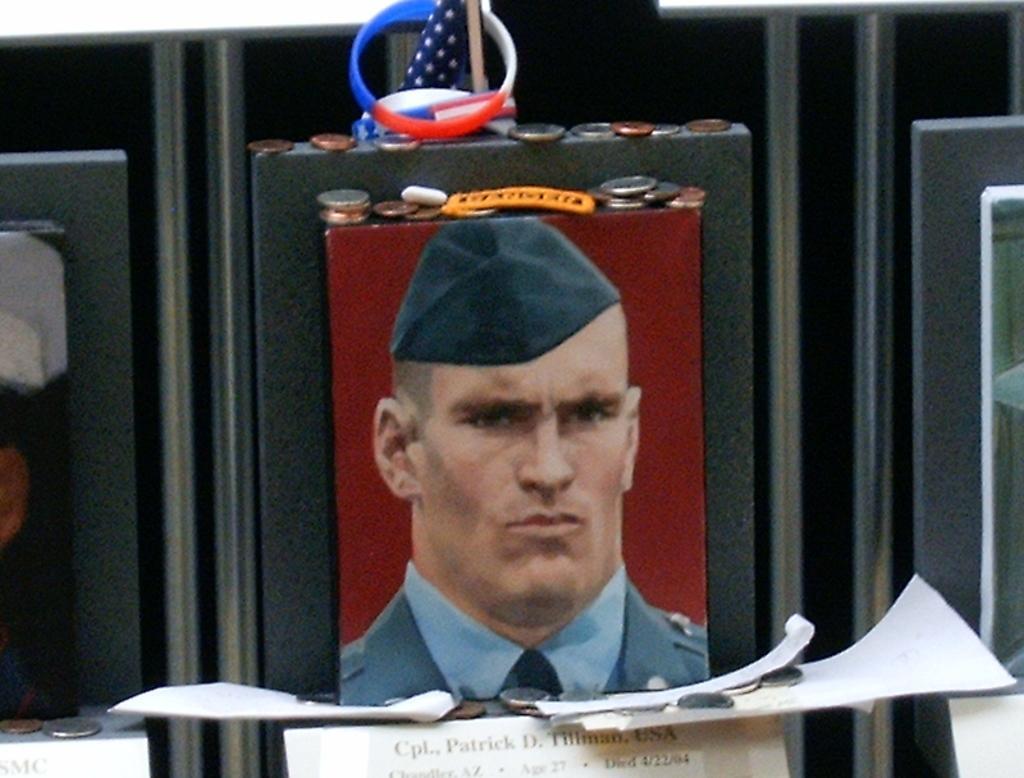How would you summarize this image in a sentence or two? In this image I can see the person's photo attached to the black color surface. And there are coins, band and flag on it. I can also see the papers in-front of the photo. 